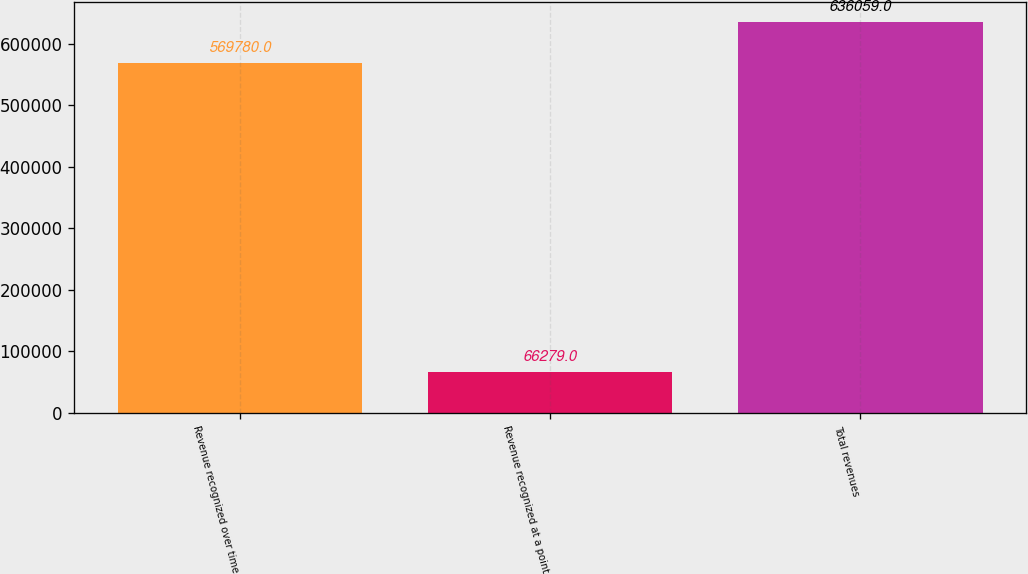Convert chart to OTSL. <chart><loc_0><loc_0><loc_500><loc_500><bar_chart><fcel>Revenue recognized over time<fcel>Revenue recognized at a point<fcel>Total revenues<nl><fcel>569780<fcel>66279<fcel>636059<nl></chart> 